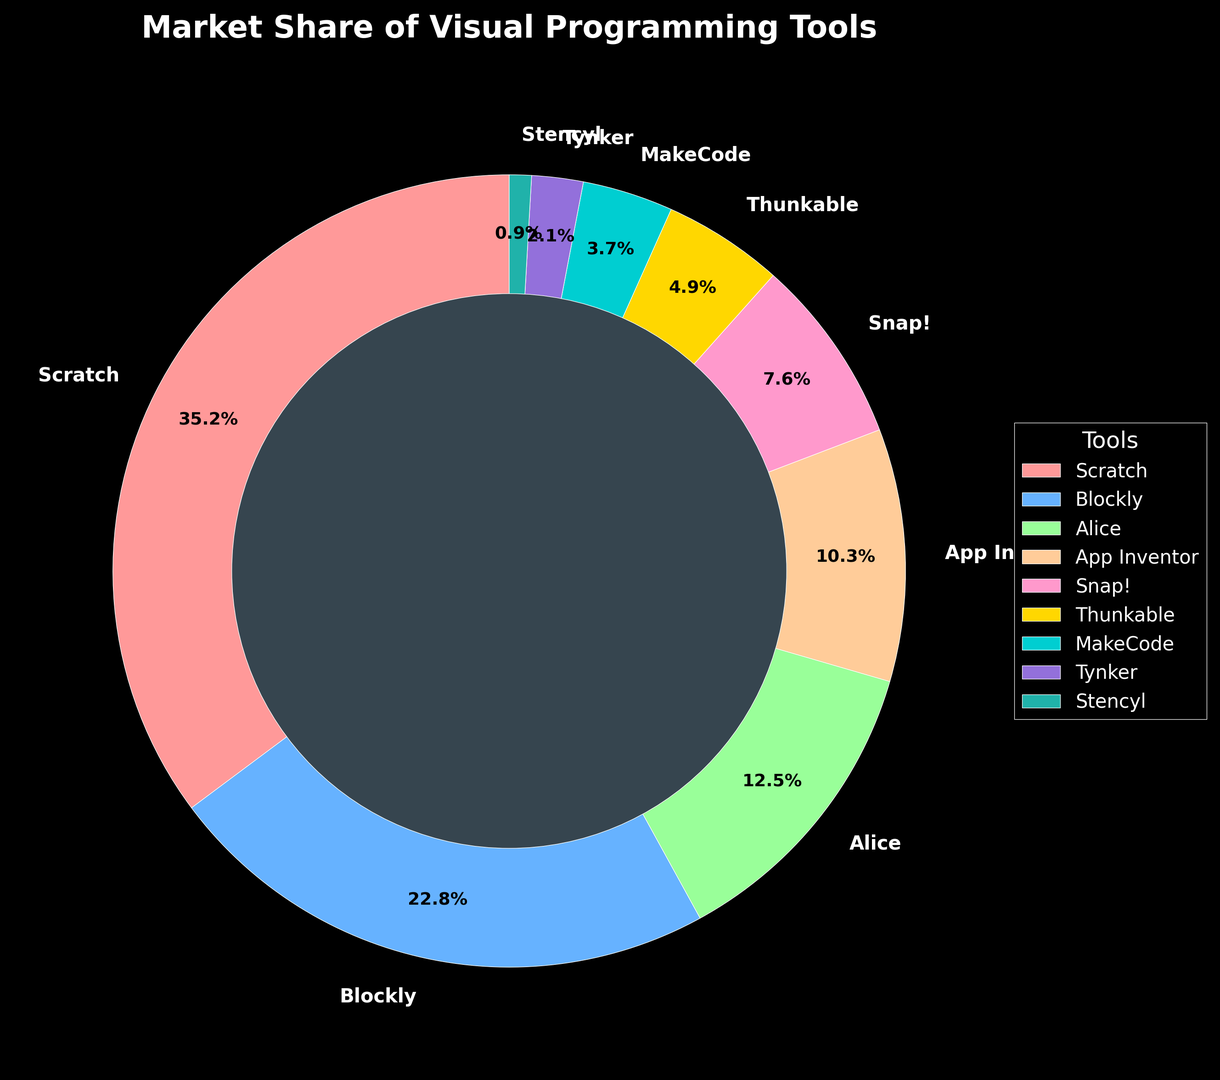What percentage of the market share do Scratch and Blockly have together? First, find the market share for Scratch (35.2%) and Blockly (22.8%). Add them together: 35.2 + 22.8 = 58%.
Answer: 58% Which tool has the lowest market share? Look for the tool with the smallest segment in the pie chart. Stencyl has the smallest portion at 0.9%.
Answer: Stencyl How much higher is Snap!'s market share compared to MakeCode? Find Snap!'s market share (7.6%) and MakeCode's market share (3.7%). Subtract: 7.6 - 3.7 = 3.9%.
Answer: 3.9% What is the combined market share of Alice, App Inventor, and Snap!? Find the market shares of Alice (12.5%), App Inventor (10.3%), and Snap! (7.6%). Add them: 12.5 + 10.3 + 7.6 = 30.4%.
Answer: 30.4% Which tool has a higher market share, MakeCode or Tynker? Compare the market shares of MakeCode (3.7%) and Tynker (2.1%). MakeCode's share is higher.
Answer: MakeCode What is the difference between the highest and the lowest market shares? Find the highest market share (Scratch, 35.2%) and the lowest market share (Stencyl, 0.9%). Subtract: 35.2 - 0.9 = 34.3%.
Answer: 34.3% Which tool has a market share closest to one-third of Scratch’s market share? Calculate one-third of Scratch's market share: 35.2 / 3 ≈ 11.73%. The closest market share to this is Alice's at 12.5%.
Answer: Alice What fraction of the total market do Snap! and Thunkable share together? Find Snap!'s market share (7.6%) and Thunkable's (4.9%). Sum them: 7.6 + 4.9 = 12.5%. To express as a fraction of 100%, it's 12.5/100 = 1/8.
Answer: 1/8 How many tools have a market share greater than 10%? Count the tools with market shares greater than 10%. They are Scratch (35.2%), Blockly (22.8%), Alice (12.5%), and App Inventor (10.3%). There are 4 such tools.
Answer: 4 